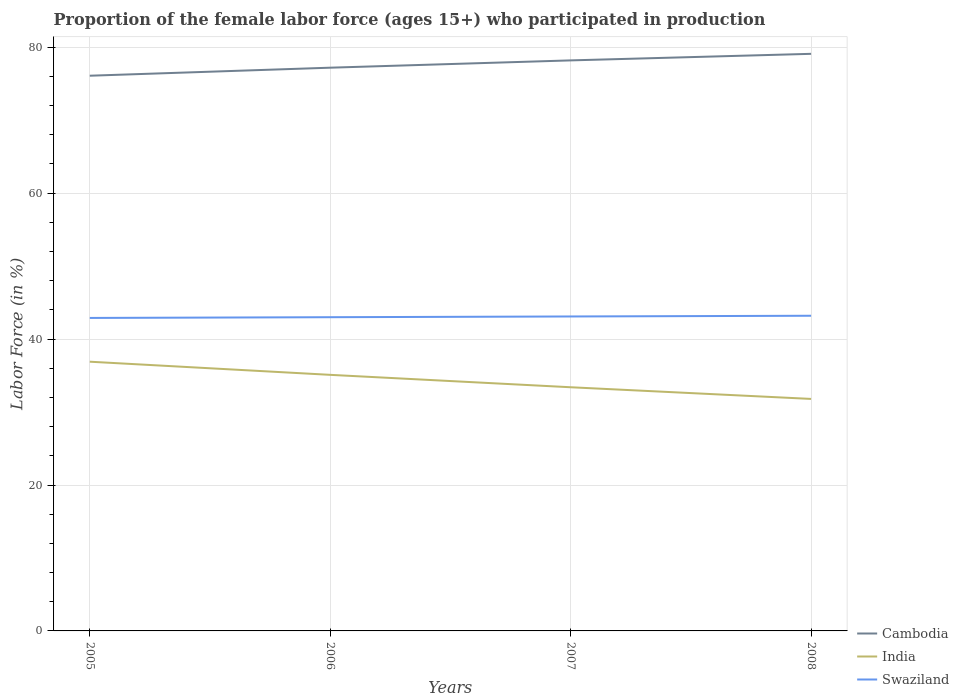Is the number of lines equal to the number of legend labels?
Provide a succinct answer. Yes. Across all years, what is the maximum proportion of the female labor force who participated in production in India?
Offer a very short reply. 31.8. In which year was the proportion of the female labor force who participated in production in Swaziland maximum?
Give a very brief answer. 2005. What is the total proportion of the female labor force who participated in production in Cambodia in the graph?
Provide a succinct answer. -1. What is the difference between the highest and the second highest proportion of the female labor force who participated in production in India?
Your response must be concise. 5.1. Is the proportion of the female labor force who participated in production in India strictly greater than the proportion of the female labor force who participated in production in Swaziland over the years?
Give a very brief answer. Yes. How many years are there in the graph?
Ensure brevity in your answer.  4. Does the graph contain any zero values?
Provide a succinct answer. No. Does the graph contain grids?
Offer a very short reply. Yes. Where does the legend appear in the graph?
Provide a short and direct response. Bottom right. How many legend labels are there?
Your answer should be compact. 3. How are the legend labels stacked?
Give a very brief answer. Vertical. What is the title of the graph?
Your answer should be compact. Proportion of the female labor force (ages 15+) who participated in production. Does "Vietnam" appear as one of the legend labels in the graph?
Offer a terse response. No. What is the label or title of the X-axis?
Give a very brief answer. Years. What is the Labor Force (in %) of Cambodia in 2005?
Your answer should be very brief. 76.1. What is the Labor Force (in %) in India in 2005?
Give a very brief answer. 36.9. What is the Labor Force (in %) in Swaziland in 2005?
Offer a terse response. 42.9. What is the Labor Force (in %) in Cambodia in 2006?
Your answer should be very brief. 77.2. What is the Labor Force (in %) in India in 2006?
Ensure brevity in your answer.  35.1. What is the Labor Force (in %) of Swaziland in 2006?
Make the answer very short. 43. What is the Labor Force (in %) in Cambodia in 2007?
Provide a succinct answer. 78.2. What is the Labor Force (in %) in India in 2007?
Provide a short and direct response. 33.4. What is the Labor Force (in %) of Swaziland in 2007?
Your answer should be very brief. 43.1. What is the Labor Force (in %) in Cambodia in 2008?
Provide a succinct answer. 79.1. What is the Labor Force (in %) of India in 2008?
Keep it short and to the point. 31.8. What is the Labor Force (in %) in Swaziland in 2008?
Offer a very short reply. 43.2. Across all years, what is the maximum Labor Force (in %) in Cambodia?
Offer a terse response. 79.1. Across all years, what is the maximum Labor Force (in %) of India?
Make the answer very short. 36.9. Across all years, what is the maximum Labor Force (in %) of Swaziland?
Make the answer very short. 43.2. Across all years, what is the minimum Labor Force (in %) in Cambodia?
Ensure brevity in your answer.  76.1. Across all years, what is the minimum Labor Force (in %) of India?
Make the answer very short. 31.8. Across all years, what is the minimum Labor Force (in %) of Swaziland?
Keep it short and to the point. 42.9. What is the total Labor Force (in %) of Cambodia in the graph?
Offer a very short reply. 310.6. What is the total Labor Force (in %) of India in the graph?
Provide a short and direct response. 137.2. What is the total Labor Force (in %) of Swaziland in the graph?
Keep it short and to the point. 172.2. What is the difference between the Labor Force (in %) of Cambodia in 2005 and that in 2006?
Make the answer very short. -1.1. What is the difference between the Labor Force (in %) in Cambodia in 2005 and that in 2007?
Offer a terse response. -2.1. What is the difference between the Labor Force (in %) in Cambodia in 2005 and that in 2008?
Your answer should be very brief. -3. What is the difference between the Labor Force (in %) in India in 2005 and that in 2008?
Provide a short and direct response. 5.1. What is the difference between the Labor Force (in %) in Swaziland in 2005 and that in 2008?
Make the answer very short. -0.3. What is the difference between the Labor Force (in %) of Cambodia in 2006 and that in 2007?
Offer a terse response. -1. What is the difference between the Labor Force (in %) of India in 2006 and that in 2007?
Provide a short and direct response. 1.7. What is the difference between the Labor Force (in %) in Swaziland in 2006 and that in 2007?
Your answer should be compact. -0.1. What is the difference between the Labor Force (in %) in India in 2006 and that in 2008?
Your response must be concise. 3.3. What is the difference between the Labor Force (in %) in Swaziland in 2006 and that in 2008?
Provide a succinct answer. -0.2. What is the difference between the Labor Force (in %) of Cambodia in 2005 and the Labor Force (in %) of India in 2006?
Give a very brief answer. 41. What is the difference between the Labor Force (in %) of Cambodia in 2005 and the Labor Force (in %) of Swaziland in 2006?
Provide a succinct answer. 33.1. What is the difference between the Labor Force (in %) of Cambodia in 2005 and the Labor Force (in %) of India in 2007?
Ensure brevity in your answer.  42.7. What is the difference between the Labor Force (in %) of Cambodia in 2005 and the Labor Force (in %) of Swaziland in 2007?
Make the answer very short. 33. What is the difference between the Labor Force (in %) in India in 2005 and the Labor Force (in %) in Swaziland in 2007?
Make the answer very short. -6.2. What is the difference between the Labor Force (in %) in Cambodia in 2005 and the Labor Force (in %) in India in 2008?
Offer a very short reply. 44.3. What is the difference between the Labor Force (in %) in Cambodia in 2005 and the Labor Force (in %) in Swaziland in 2008?
Offer a very short reply. 32.9. What is the difference between the Labor Force (in %) of India in 2005 and the Labor Force (in %) of Swaziland in 2008?
Your answer should be compact. -6.3. What is the difference between the Labor Force (in %) of Cambodia in 2006 and the Labor Force (in %) of India in 2007?
Provide a succinct answer. 43.8. What is the difference between the Labor Force (in %) in Cambodia in 2006 and the Labor Force (in %) in Swaziland in 2007?
Make the answer very short. 34.1. What is the difference between the Labor Force (in %) in Cambodia in 2006 and the Labor Force (in %) in India in 2008?
Your answer should be very brief. 45.4. What is the difference between the Labor Force (in %) in India in 2006 and the Labor Force (in %) in Swaziland in 2008?
Your answer should be very brief. -8.1. What is the difference between the Labor Force (in %) in Cambodia in 2007 and the Labor Force (in %) in India in 2008?
Offer a terse response. 46.4. What is the difference between the Labor Force (in %) in Cambodia in 2007 and the Labor Force (in %) in Swaziland in 2008?
Your answer should be compact. 35. What is the average Labor Force (in %) in Cambodia per year?
Offer a very short reply. 77.65. What is the average Labor Force (in %) of India per year?
Provide a short and direct response. 34.3. What is the average Labor Force (in %) in Swaziland per year?
Your answer should be compact. 43.05. In the year 2005, what is the difference between the Labor Force (in %) in Cambodia and Labor Force (in %) in India?
Your answer should be very brief. 39.2. In the year 2005, what is the difference between the Labor Force (in %) of Cambodia and Labor Force (in %) of Swaziland?
Your answer should be very brief. 33.2. In the year 2005, what is the difference between the Labor Force (in %) in India and Labor Force (in %) in Swaziland?
Offer a terse response. -6. In the year 2006, what is the difference between the Labor Force (in %) in Cambodia and Labor Force (in %) in India?
Ensure brevity in your answer.  42.1. In the year 2006, what is the difference between the Labor Force (in %) in Cambodia and Labor Force (in %) in Swaziland?
Offer a terse response. 34.2. In the year 2007, what is the difference between the Labor Force (in %) of Cambodia and Labor Force (in %) of India?
Keep it short and to the point. 44.8. In the year 2007, what is the difference between the Labor Force (in %) of Cambodia and Labor Force (in %) of Swaziland?
Offer a very short reply. 35.1. In the year 2008, what is the difference between the Labor Force (in %) in Cambodia and Labor Force (in %) in India?
Your response must be concise. 47.3. In the year 2008, what is the difference between the Labor Force (in %) of Cambodia and Labor Force (in %) of Swaziland?
Give a very brief answer. 35.9. In the year 2008, what is the difference between the Labor Force (in %) in India and Labor Force (in %) in Swaziland?
Ensure brevity in your answer.  -11.4. What is the ratio of the Labor Force (in %) of Cambodia in 2005 to that in 2006?
Provide a succinct answer. 0.99. What is the ratio of the Labor Force (in %) of India in 2005 to that in 2006?
Your answer should be compact. 1.05. What is the ratio of the Labor Force (in %) of Swaziland in 2005 to that in 2006?
Keep it short and to the point. 1. What is the ratio of the Labor Force (in %) in Cambodia in 2005 to that in 2007?
Give a very brief answer. 0.97. What is the ratio of the Labor Force (in %) of India in 2005 to that in 2007?
Your response must be concise. 1.1. What is the ratio of the Labor Force (in %) in Cambodia in 2005 to that in 2008?
Provide a short and direct response. 0.96. What is the ratio of the Labor Force (in %) in India in 2005 to that in 2008?
Provide a succinct answer. 1.16. What is the ratio of the Labor Force (in %) of Cambodia in 2006 to that in 2007?
Your response must be concise. 0.99. What is the ratio of the Labor Force (in %) in India in 2006 to that in 2007?
Offer a terse response. 1.05. What is the ratio of the Labor Force (in %) of Cambodia in 2006 to that in 2008?
Your response must be concise. 0.98. What is the ratio of the Labor Force (in %) of India in 2006 to that in 2008?
Offer a terse response. 1.1. What is the ratio of the Labor Force (in %) in India in 2007 to that in 2008?
Ensure brevity in your answer.  1.05. What is the ratio of the Labor Force (in %) in Swaziland in 2007 to that in 2008?
Make the answer very short. 1. What is the difference between the highest and the second highest Labor Force (in %) in Cambodia?
Make the answer very short. 0.9. What is the difference between the highest and the second highest Labor Force (in %) in India?
Provide a succinct answer. 1.8. 